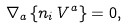Convert formula to latex. <formula><loc_0><loc_0><loc_500><loc_500>\nabla _ { a } \left \{ n _ { i } \, V ^ { a } \right \} = 0 ,</formula> 